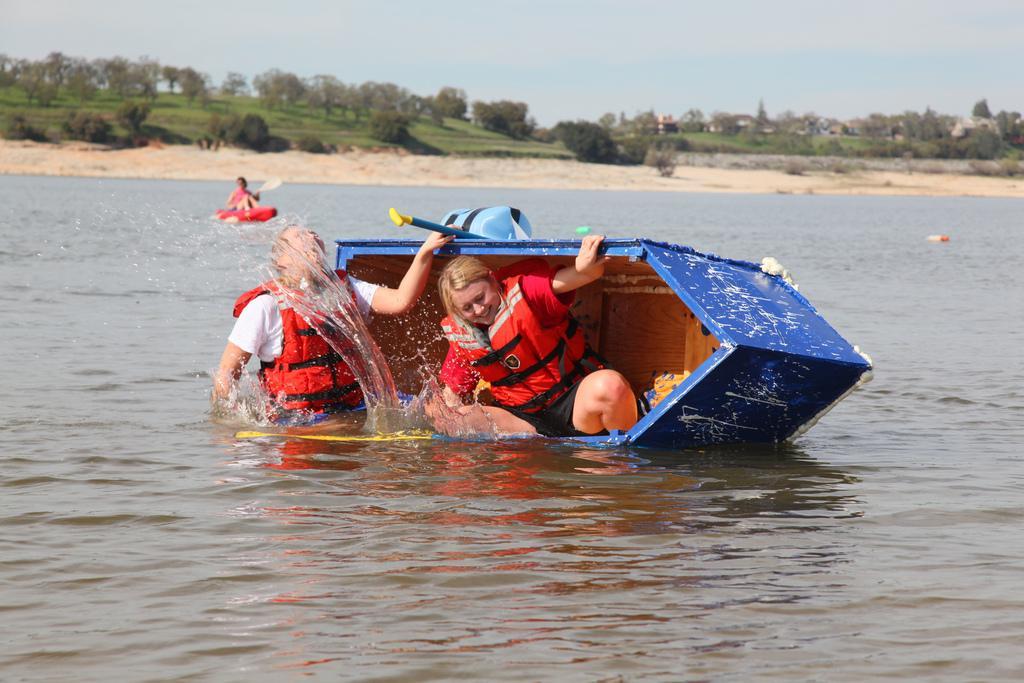Could you give a brief overview of what you see in this image? In the center of the image we can see two people are sitting in a boat and wearing the jackets. In the background of the image we can see the trees, grass, buildings, soil, water and a person is sitting in a boat and holding a stick. At the top of the image we can see the sky. 